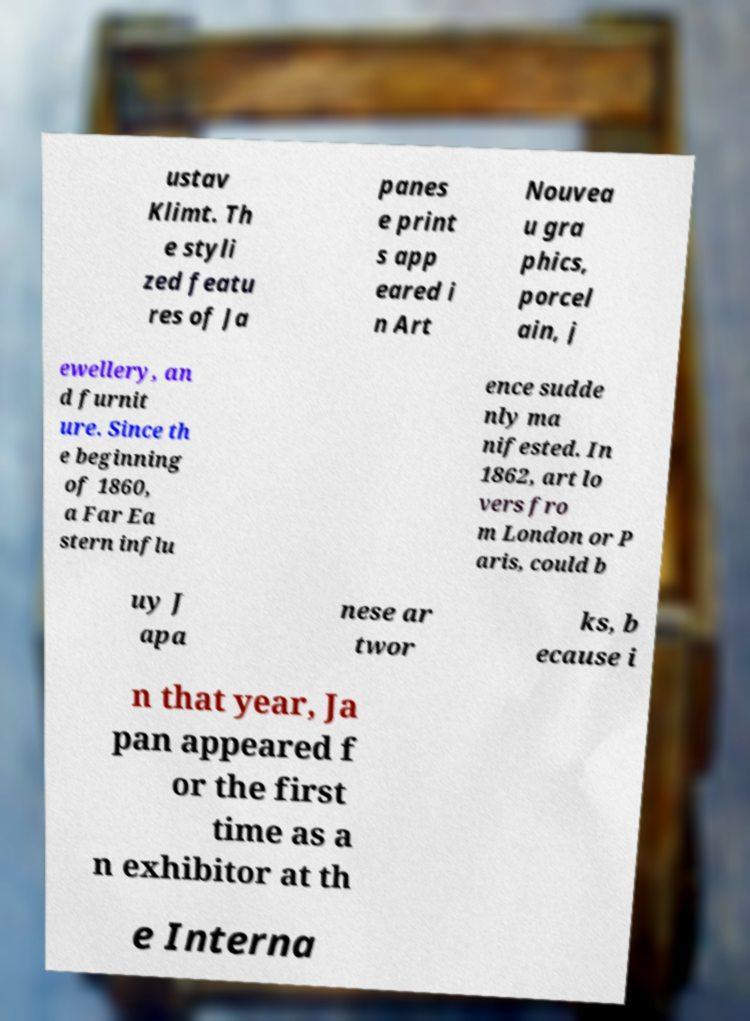For documentation purposes, I need the text within this image transcribed. Could you provide that? ustav Klimt. Th e styli zed featu res of Ja panes e print s app eared i n Art Nouvea u gra phics, porcel ain, j ewellery, an d furnit ure. Since th e beginning of 1860, a Far Ea stern influ ence sudde nly ma nifested. In 1862, art lo vers fro m London or P aris, could b uy J apa nese ar twor ks, b ecause i n that year, Ja pan appeared f or the first time as a n exhibitor at th e Interna 